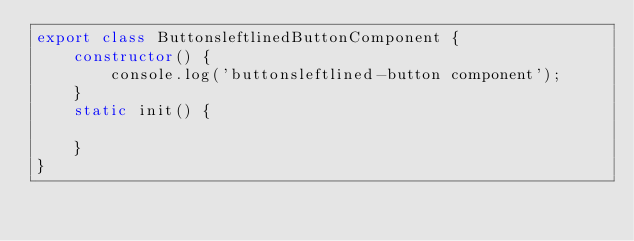<code> <loc_0><loc_0><loc_500><loc_500><_TypeScript_>export class ButtonsleftlinedButtonComponent {
	constructor() {
		console.log('buttonsleftlined-button component');
	}
	static init() {

	}
}</code> 